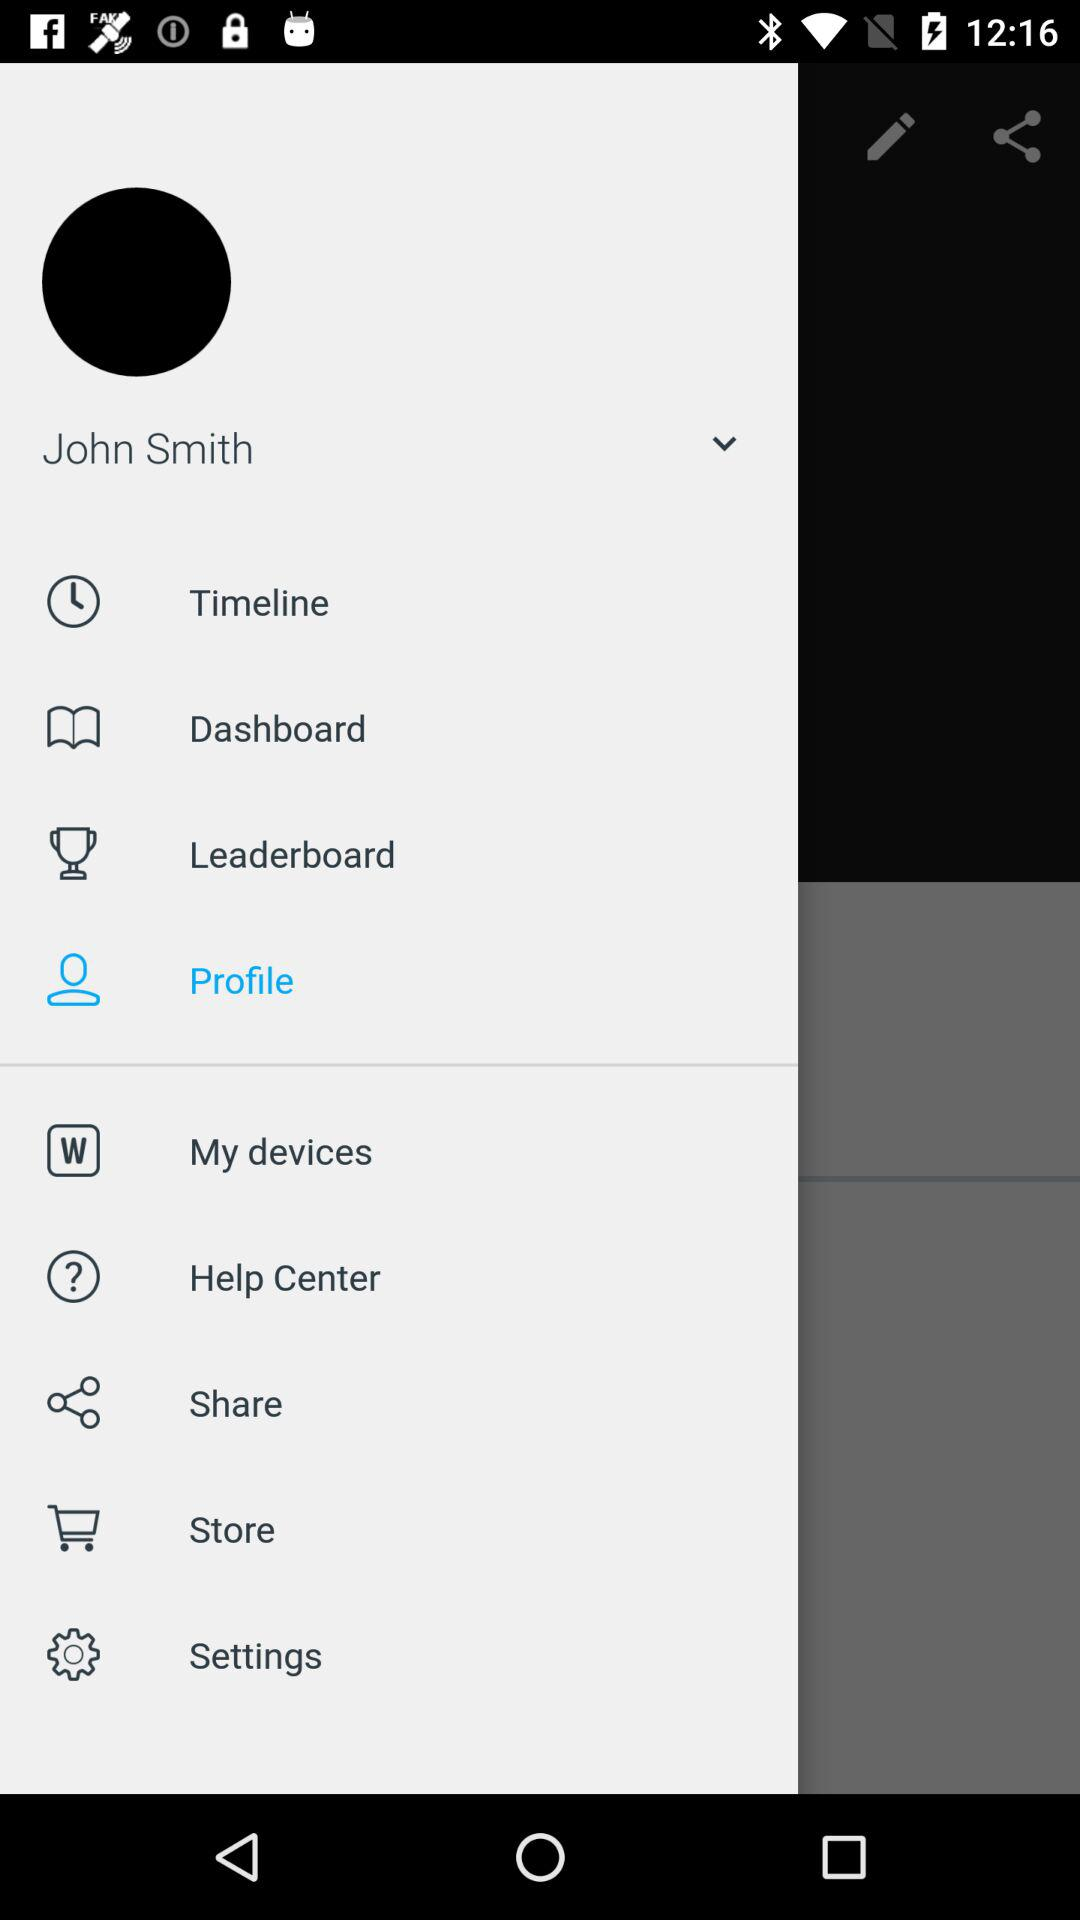What is the selected option? The selected option is "Profile". 